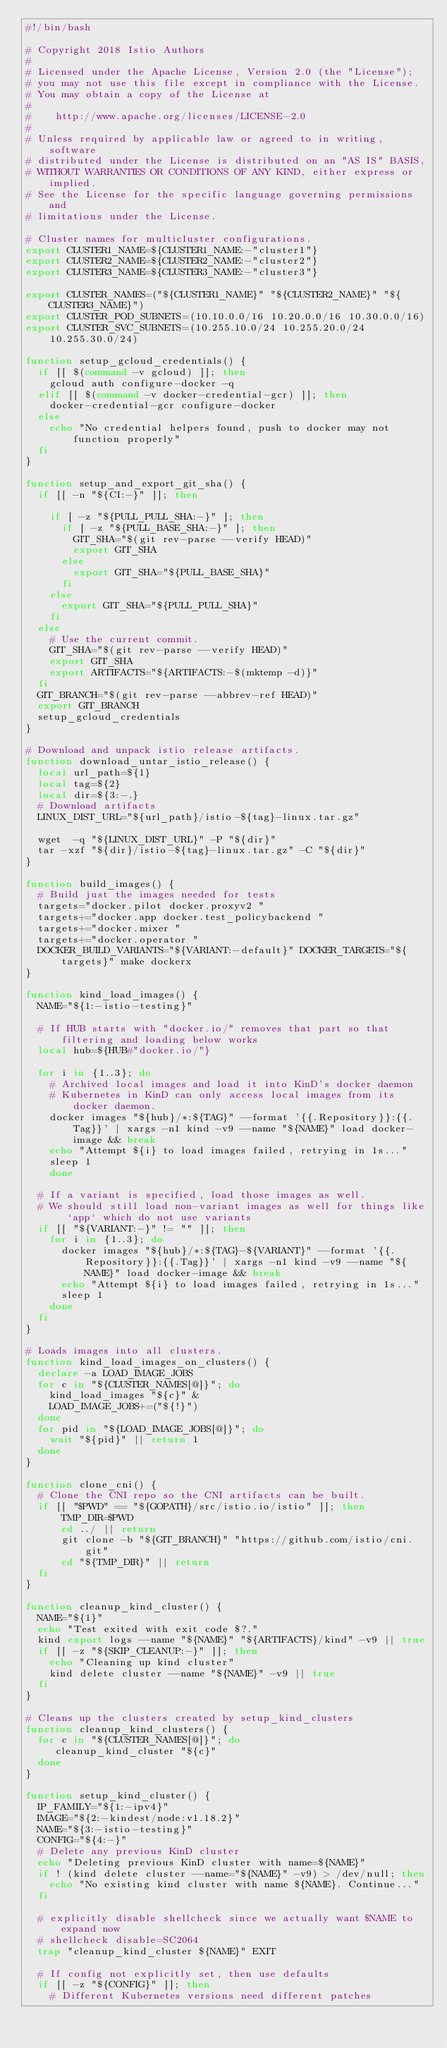<code> <loc_0><loc_0><loc_500><loc_500><_Bash_>#!/bin/bash

# Copyright 2018 Istio Authors
#
# Licensed under the Apache License, Version 2.0 (the "License");
# you may not use this file except in compliance with the License.
# You may obtain a copy of the License at
#
#    http://www.apache.org/licenses/LICENSE-2.0
#
# Unless required by applicable law or agreed to in writing, software
# distributed under the License is distributed on an "AS IS" BASIS,
# WITHOUT WARRANTIES OR CONDITIONS OF ANY KIND, either express or implied.
# See the License for the specific language governing permissions and
# limitations under the License.

# Cluster names for multicluster configurations.
export CLUSTER1_NAME=${CLUSTER1_NAME:-"cluster1"}
export CLUSTER2_NAME=${CLUSTER2_NAME:-"cluster2"}
export CLUSTER3_NAME=${CLUSTER3_NAME:-"cluster3"}

export CLUSTER_NAMES=("${CLUSTER1_NAME}" "${CLUSTER2_NAME}" "${CLUSTER3_NAME}")
export CLUSTER_POD_SUBNETS=(10.10.0.0/16 10.20.0.0/16 10.30.0.0/16)
export CLUSTER_SVC_SUBNETS=(10.255.10.0/24 10.255.20.0/24 10.255.30.0/24)

function setup_gcloud_credentials() {
  if [[ $(command -v gcloud) ]]; then
    gcloud auth configure-docker -q
  elif [[ $(command -v docker-credential-gcr) ]]; then
    docker-credential-gcr configure-docker
  else
    echo "No credential helpers found, push to docker may not function properly"
  fi
}

function setup_and_export_git_sha() {
  if [[ -n "${CI:-}" ]]; then

    if [ -z "${PULL_PULL_SHA:-}" ]; then
      if [ -z "${PULL_BASE_SHA:-}" ]; then
        GIT_SHA="$(git rev-parse --verify HEAD)"
        export GIT_SHA
      else
        export GIT_SHA="${PULL_BASE_SHA}"
      fi
    else
      export GIT_SHA="${PULL_PULL_SHA}"
    fi
  else
    # Use the current commit.
    GIT_SHA="$(git rev-parse --verify HEAD)"
    export GIT_SHA
    export ARTIFACTS="${ARTIFACTS:-$(mktemp -d)}"
  fi
  GIT_BRANCH="$(git rev-parse --abbrev-ref HEAD)"
  export GIT_BRANCH
  setup_gcloud_credentials
}

# Download and unpack istio release artifacts.
function download_untar_istio_release() {
  local url_path=${1}
  local tag=${2}
  local dir=${3:-.}
  # Download artifacts
  LINUX_DIST_URL="${url_path}/istio-${tag}-linux.tar.gz"

  wget  -q "${LINUX_DIST_URL}" -P "${dir}"
  tar -xzf "${dir}/istio-${tag}-linux.tar.gz" -C "${dir}"
}

function build_images() {
  # Build just the images needed for tests
  targets="docker.pilot docker.proxyv2 "
  targets+="docker.app docker.test_policybackend "
  targets+="docker.mixer "
  targets+="docker.operator "
  DOCKER_BUILD_VARIANTS="${VARIANT:-default}" DOCKER_TARGETS="${targets}" make dockerx
}

function kind_load_images() {
  NAME="${1:-istio-testing}"

  # If HUB starts with "docker.io/" removes that part so that filtering and loading below works
  local hub=${HUB#"docker.io/"}

  for i in {1..3}; do
    # Archived local images and load it into KinD's docker daemon
    # Kubernetes in KinD can only access local images from its docker daemon.
    docker images "${hub}/*:${TAG}" --format '{{.Repository}}:{{.Tag}}' | xargs -n1 kind -v9 --name "${NAME}" load docker-image && break
    echo "Attempt ${i} to load images failed, retrying in 1s..."
    sleep 1
	done

  # If a variant is specified, load those images as well.
  # We should still load non-variant images as well for things like `app` which do not use variants
  if [[ "${VARIANT:-}" != "" ]]; then
    for i in {1..3}; do
      docker images "${hub}/*:${TAG}-${VARIANT}" --format '{{.Repository}}:{{.Tag}}' | xargs -n1 kind -v9 --name "${NAME}" load docker-image && break
      echo "Attempt ${i} to load images failed, retrying in 1s..."
      sleep 1
    done
  fi
}

# Loads images into all clusters.
function kind_load_images_on_clusters() {
  declare -a LOAD_IMAGE_JOBS
  for c in "${CLUSTER_NAMES[@]}"; do
    kind_load_images "${c}" &
    LOAD_IMAGE_JOBS+=("${!}")
  done
  for pid in "${LOAD_IMAGE_JOBS[@]}"; do
    wait "${pid}" || return 1
  done
}

function clone_cni() {
  # Clone the CNI repo so the CNI artifacts can be built.
  if [[ "$PWD" == "${GOPATH}/src/istio.io/istio" ]]; then
      TMP_DIR=$PWD
      cd ../ || return
      git clone -b "${GIT_BRANCH}" "https://github.com/istio/cni.git"
      cd "${TMP_DIR}" || return
  fi
}

function cleanup_kind_cluster() {
  NAME="${1}"
  echo "Test exited with exit code $?."
  kind export logs --name "${NAME}" "${ARTIFACTS}/kind" -v9 || true
  if [[ -z "${SKIP_CLEANUP:-}" ]]; then
    echo "Cleaning up kind cluster"
    kind delete cluster --name "${NAME}" -v9 || true
  fi
}

# Cleans up the clusters created by setup_kind_clusters
function cleanup_kind_clusters() {
  for c in "${CLUSTER_NAMES[@]}"; do
     cleanup_kind_cluster "${c}"
  done
}

function setup_kind_cluster() {
  IP_FAMILY="${1:-ipv4}"
  IMAGE="${2:-kindest/node:v1.18.2}"
  NAME="${3:-istio-testing}"
  CONFIG="${4:-}"
  # Delete any previous KinD cluster
  echo "Deleting previous KinD cluster with name=${NAME}"
  if ! (kind delete cluster --name="${NAME}" -v9) > /dev/null; then
    echo "No existing kind cluster with name ${NAME}. Continue..."
  fi

  # explicitly disable shellcheck since we actually want $NAME to expand now
  # shellcheck disable=SC2064
  trap "cleanup_kind_cluster ${NAME}" EXIT

  # If config not explicitly set, then use defaults
  if [[ -z "${CONFIG}" ]]; then
    # Different Kubernetes versions need different patches</code> 